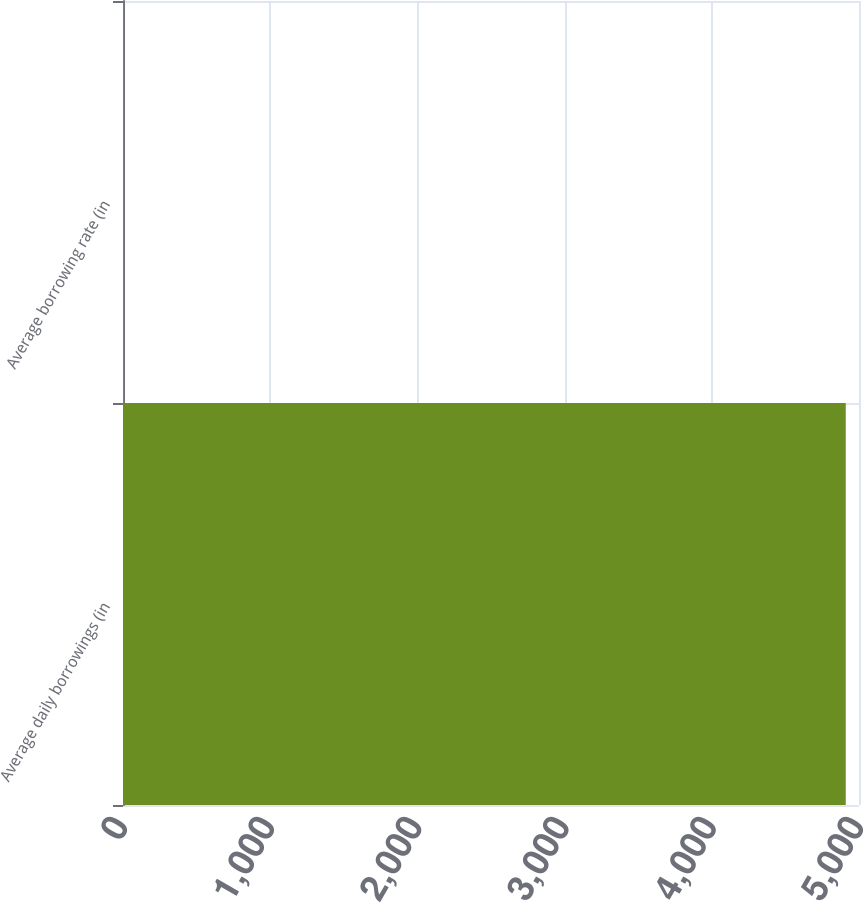Convert chart. <chart><loc_0><loc_0><loc_500><loc_500><bar_chart><fcel>Average daily borrowings (in<fcel>Average borrowing rate (in<nl><fcel>4910<fcel>6.6<nl></chart> 